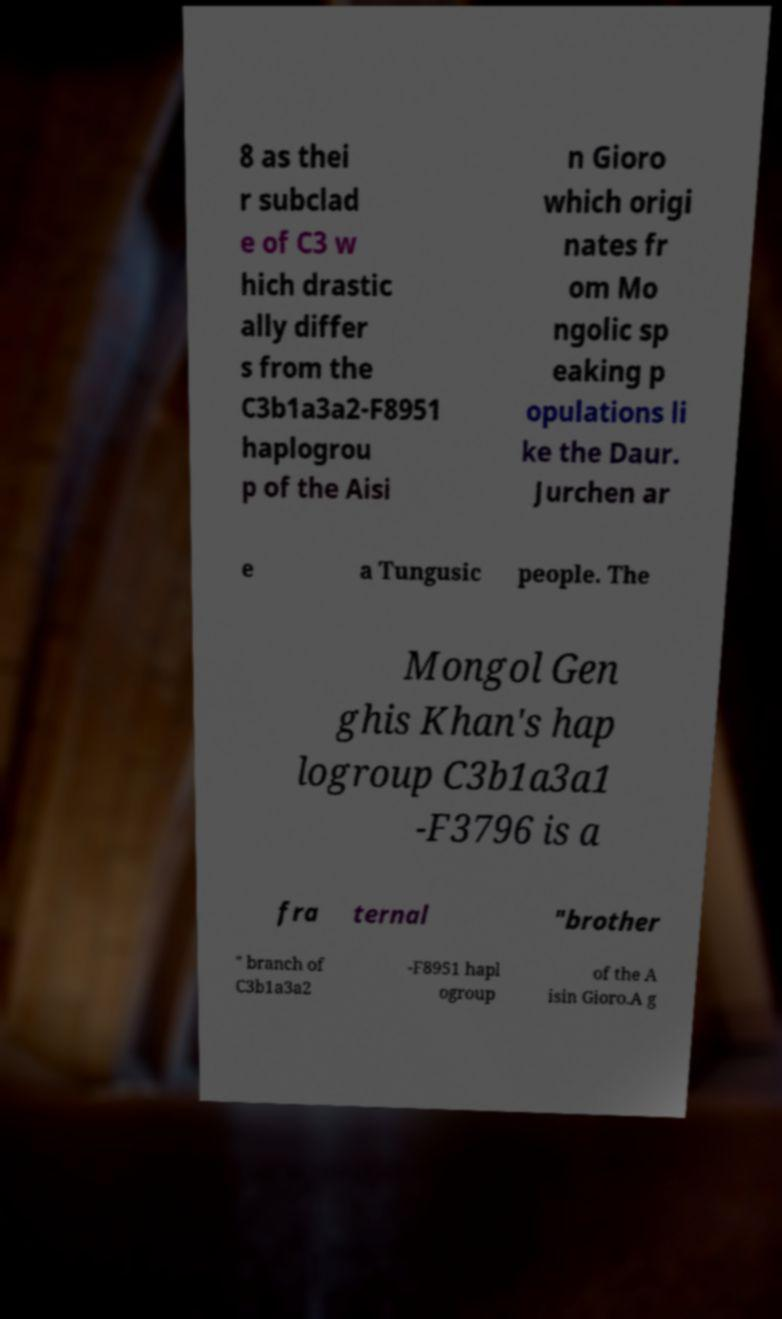There's text embedded in this image that I need extracted. Can you transcribe it verbatim? 8 as thei r subclad e of C3 w hich drastic ally differ s from the C3b1a3a2-F8951 haplogrou p of the Aisi n Gioro which origi nates fr om Mo ngolic sp eaking p opulations li ke the Daur. Jurchen ar e a Tungusic people. The Mongol Gen ghis Khan's hap logroup C3b1a3a1 -F3796 is a fra ternal "brother " branch of C3b1a3a2 -F8951 hapl ogroup of the A isin Gioro.A g 